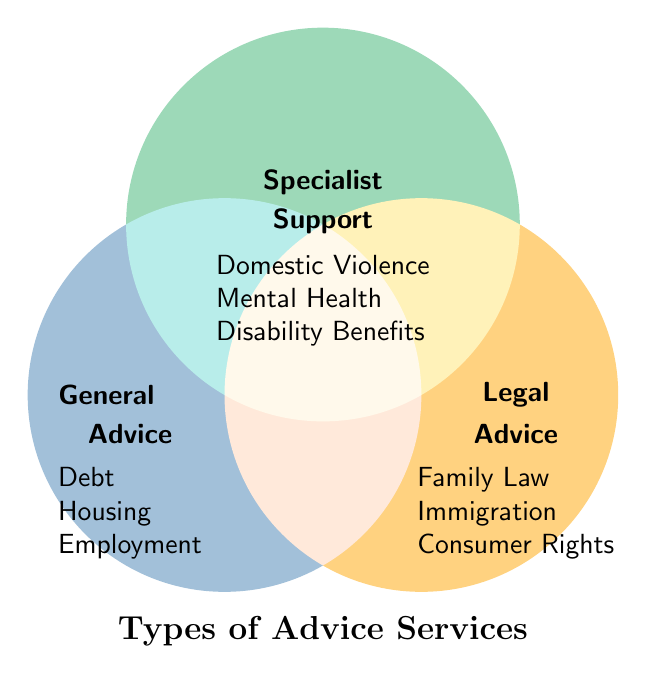What is the title of the figure? The title is usually at the top or bottom of the figure and is meant to describe the content of the chart. In this case, the title is positioned at the bottom of the Venn diagram.
Answer: Types of Advice Services Which areas contain "Debt", "Housing", and "Employment"? "Debt", "Housing", and "Employment" are listed under the "General Advice" category, which is represented by the blue circle on the left side of the Venn diagram.
Answer: General Advice Which service is not related to legal or specialist categories? By observing the services listed, "Debt", "Housing", and "Employment" are only mentioned under the General Advice category and don’t overlap with the other categories (Legal Advice and Specialist Support).
Answer: Debt, Housing, Employment Which color represents "Legal Advice" services? The color representing "Legal Advice" services can be determined by looking at the figure. The category "Legal Advice" is associated with the orange circle on the right side.
Answer: Orange Which services are associated with "Specialist Support"? The services noted under "Specialist Support" can be identified by looking at the text inside the green circle at the top of the diagram. These services are "Domestic Violence", "Mental Health", and "Disability Benefits".
Answer: Domestic Violence, Mental Health, Disability Benefits What categories intersect with "General Advice"? To answer this, identify whether there is any geographical overlap in the Venn diagram between the "General Advice" circle and the other circles. In the given diagram, there is no overlap between "General Advice", "Legal Advice", and "Specialist Support".
Answer: None How many services are listed under "Legal Advice"? Counting the services inside the "Legal Advice" category in the Venn diagram will give the answer. These services are "Family Law", "Immigration", and "Consumer Rights", which totals three services.
Answer: 3 Which category includes "Family Law"? "Family Law" is found within the text placed in the orange "Legal Advice" circle on the right side of the Venn diagram.
Answer: Legal Advice Which service is listed under "Specialist Support" but not under "General Advice" or "Legal Advice"? By comparing services listed among the three categories, "Domestic Violence", "Mental Health", and "Disability Benefits" fall solely under "Specialist Support" without overlapping with other categories.
Answer: Domestic Violence, Mental Health, Disability Benefits Are there any services common to all three categories in a central overlap? In a Venn diagram, a common service to all categories would be placed in the central portion where all circles overlap. Since there are no services listed in this central overlapping section, there are no common services.
Answer: No 